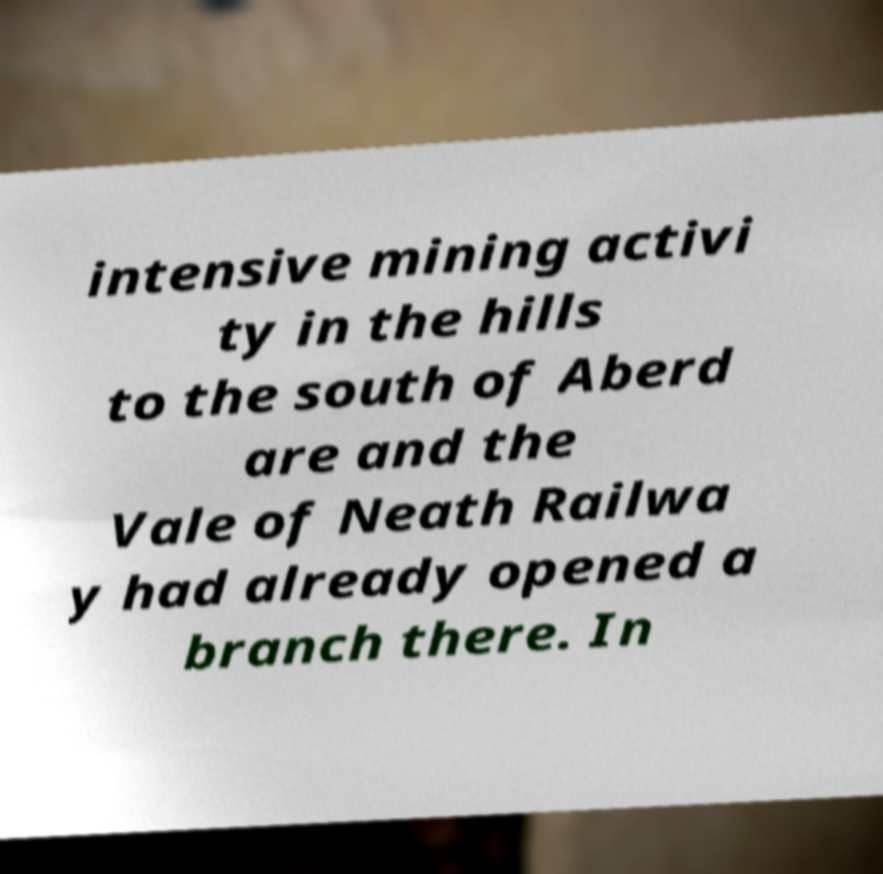There's text embedded in this image that I need extracted. Can you transcribe it verbatim? intensive mining activi ty in the hills to the south of Aberd are and the Vale of Neath Railwa y had already opened a branch there. In 